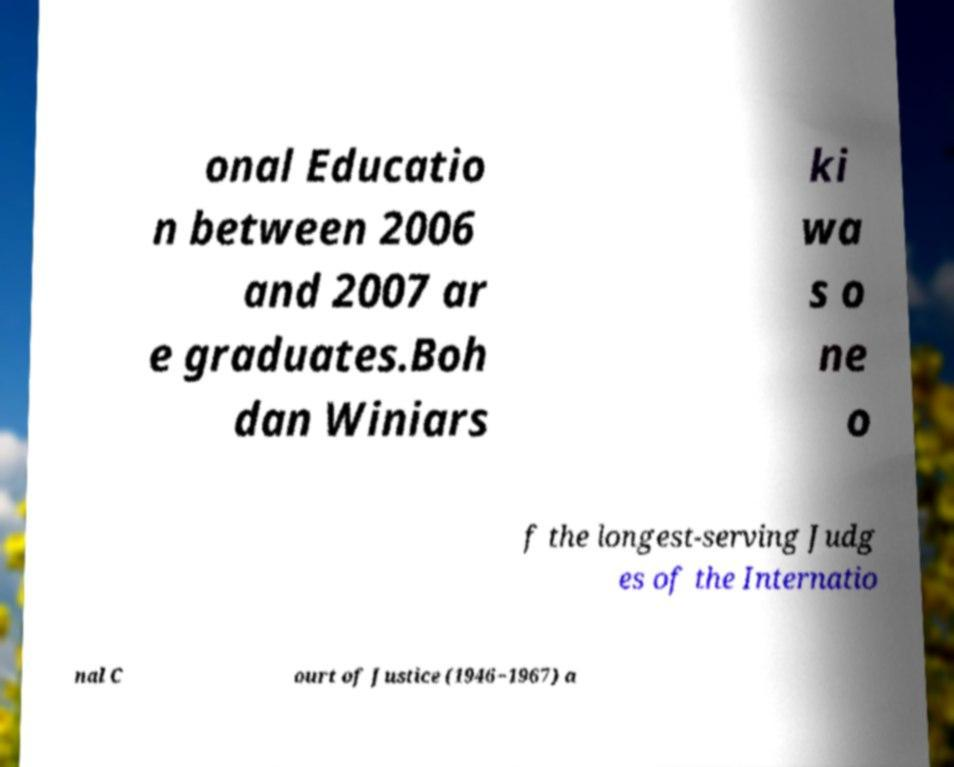What messages or text are displayed in this image? I need them in a readable, typed format. onal Educatio n between 2006 and 2007 ar e graduates.Boh dan Winiars ki wa s o ne o f the longest-serving Judg es of the Internatio nal C ourt of Justice (1946−1967) a 